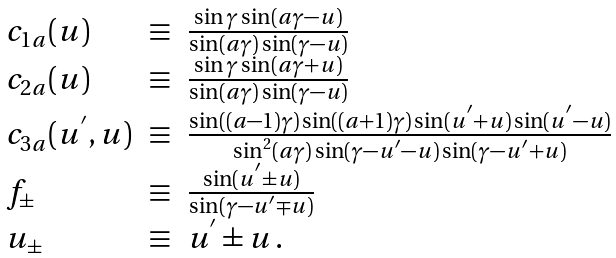<formula> <loc_0><loc_0><loc_500><loc_500>\begin{array} { l l l } { { c _ { 1 a } ( u ) } } & { \equiv } & { { \frac { \sin \gamma \sin ( a \gamma - u ) } { \sin ( a \gamma ) \sin ( \gamma - u ) } } } \\ { { c _ { 2 a } ( u ) } } & { \equiv } & { { \frac { \sin \gamma \sin ( a \gamma + u ) } { \sin ( a \gamma ) \sin ( \gamma - u ) } } } \\ { { c _ { 3 a } ( u ^ { ^ { \prime } } , u ) } } & { \equiv } & { { \frac { \sin ( ( a - 1 ) \gamma ) \sin ( ( a + 1 ) \gamma ) \sin ( u ^ { ^ { \prime } } + u ) \sin ( u ^ { ^ { \prime } } - u ) } { \sin ^ { 2 } ( a \gamma ) \sin ( \gamma - u ^ { ^ { \prime } } - u ) \sin ( \gamma - u ^ { ^ { \prime } } + u ) } } } \\ { { f _ { \pm } } } & { \equiv } & { { \frac { \sin ( u ^ { ^ { \prime } } \pm u ) } { \sin ( \gamma - u ^ { ^ { \prime } } \mp u ) } } } \\ { { u _ { \pm } } } & { \equiv } & { { u ^ { ^ { \prime } } \pm u \, . } } \end{array}</formula> 